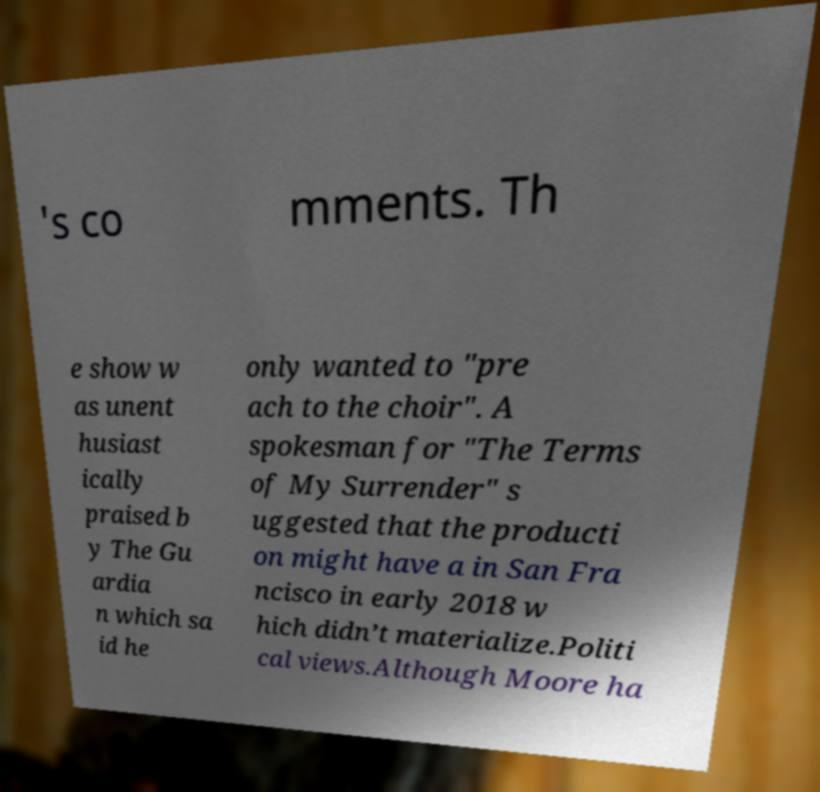Can you read and provide the text displayed in the image?This photo seems to have some interesting text. Can you extract and type it out for me? 's co mments. Th e show w as unent husiast ically praised b y The Gu ardia n which sa id he only wanted to "pre ach to the choir". A spokesman for "The Terms of My Surrender" s uggested that the producti on might have a in San Fra ncisco in early 2018 w hich didn’t materialize.Politi cal views.Although Moore ha 